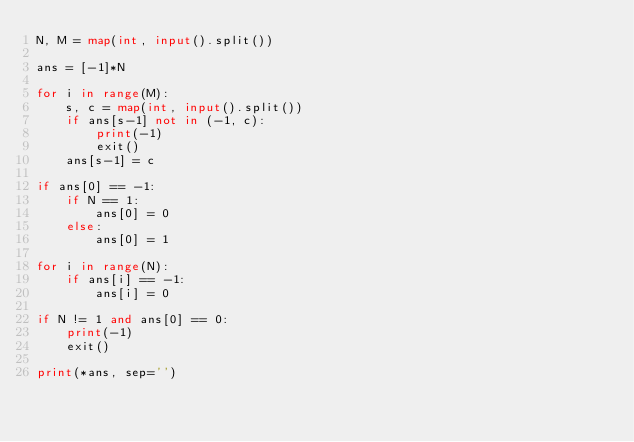Convert code to text. <code><loc_0><loc_0><loc_500><loc_500><_Python_>N, M = map(int, input().split())

ans = [-1]*N

for i in range(M):
    s, c = map(int, input().split())
    if ans[s-1] not in (-1, c):
        print(-1)
        exit()
    ans[s-1] = c

if ans[0] == -1:
    if N == 1:
        ans[0] = 0
    else:
        ans[0] = 1

for i in range(N):
    if ans[i] == -1:
        ans[i] = 0

if N != 1 and ans[0] == 0:
    print(-1)
    exit()

print(*ans, sep='')
</code> 